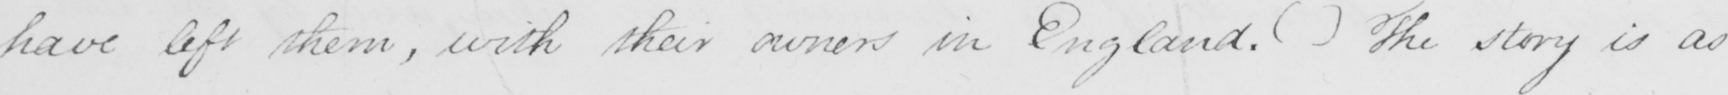Please provide the text content of this handwritten line. have left them , with their owners in England .  (   )  The story is as 